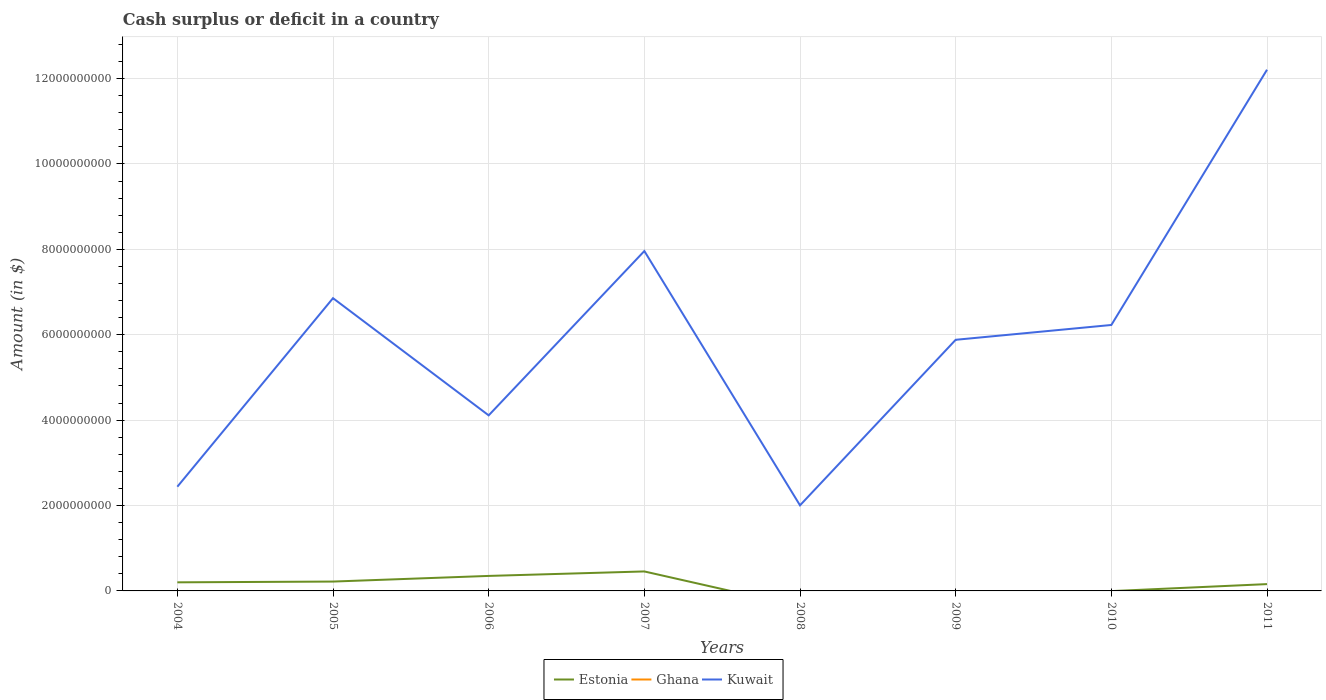How many different coloured lines are there?
Make the answer very short. 2. Does the line corresponding to Ghana intersect with the line corresponding to Estonia?
Make the answer very short. No. Across all years, what is the maximum amount of cash surplus or deficit in Kuwait?
Keep it short and to the point. 2.00e+09. What is the total amount of cash surplus or deficit in Kuwait in the graph?
Make the answer very short. -4.22e+09. What is the difference between the highest and the second highest amount of cash surplus or deficit in Estonia?
Ensure brevity in your answer.  4.56e+08. Is the amount of cash surplus or deficit in Ghana strictly greater than the amount of cash surplus or deficit in Kuwait over the years?
Offer a terse response. Yes. How many years are there in the graph?
Your response must be concise. 8. Are the values on the major ticks of Y-axis written in scientific E-notation?
Give a very brief answer. No. Does the graph contain any zero values?
Offer a terse response. Yes. Where does the legend appear in the graph?
Your answer should be very brief. Bottom center. How many legend labels are there?
Ensure brevity in your answer.  3. What is the title of the graph?
Keep it short and to the point. Cash surplus or deficit in a country. What is the label or title of the Y-axis?
Make the answer very short. Amount (in $). What is the Amount (in $) in Estonia in 2004?
Your answer should be compact. 2.01e+08. What is the Amount (in $) in Kuwait in 2004?
Ensure brevity in your answer.  2.44e+09. What is the Amount (in $) of Estonia in 2005?
Your answer should be compact. 2.19e+08. What is the Amount (in $) in Ghana in 2005?
Provide a succinct answer. 0. What is the Amount (in $) of Kuwait in 2005?
Give a very brief answer. 6.86e+09. What is the Amount (in $) of Estonia in 2006?
Offer a very short reply. 3.52e+08. What is the Amount (in $) of Ghana in 2006?
Provide a succinct answer. 0. What is the Amount (in $) of Kuwait in 2006?
Provide a succinct answer. 4.11e+09. What is the Amount (in $) of Estonia in 2007?
Provide a short and direct response. 4.56e+08. What is the Amount (in $) of Kuwait in 2007?
Your response must be concise. 7.96e+09. What is the Amount (in $) in Kuwait in 2008?
Offer a terse response. 2.00e+09. What is the Amount (in $) of Kuwait in 2009?
Your answer should be compact. 5.88e+09. What is the Amount (in $) in Kuwait in 2010?
Your answer should be very brief. 6.23e+09. What is the Amount (in $) of Estonia in 2011?
Provide a short and direct response. 1.60e+08. What is the Amount (in $) in Kuwait in 2011?
Keep it short and to the point. 1.22e+1. Across all years, what is the maximum Amount (in $) in Estonia?
Offer a very short reply. 4.56e+08. Across all years, what is the maximum Amount (in $) in Kuwait?
Your response must be concise. 1.22e+1. Across all years, what is the minimum Amount (in $) of Kuwait?
Your answer should be compact. 2.00e+09. What is the total Amount (in $) in Estonia in the graph?
Give a very brief answer. 1.39e+09. What is the total Amount (in $) of Ghana in the graph?
Offer a very short reply. 0. What is the total Amount (in $) in Kuwait in the graph?
Your answer should be compact. 4.77e+1. What is the difference between the Amount (in $) in Estonia in 2004 and that in 2005?
Ensure brevity in your answer.  -1.79e+07. What is the difference between the Amount (in $) of Kuwait in 2004 and that in 2005?
Your response must be concise. -4.42e+09. What is the difference between the Amount (in $) in Estonia in 2004 and that in 2006?
Offer a terse response. -1.50e+08. What is the difference between the Amount (in $) of Kuwait in 2004 and that in 2006?
Ensure brevity in your answer.  -1.67e+09. What is the difference between the Amount (in $) in Estonia in 2004 and that in 2007?
Give a very brief answer. -2.55e+08. What is the difference between the Amount (in $) of Kuwait in 2004 and that in 2007?
Offer a very short reply. -5.52e+09. What is the difference between the Amount (in $) in Kuwait in 2004 and that in 2008?
Your answer should be very brief. 4.36e+08. What is the difference between the Amount (in $) in Kuwait in 2004 and that in 2009?
Your response must be concise. -3.44e+09. What is the difference between the Amount (in $) in Kuwait in 2004 and that in 2010?
Make the answer very short. -3.79e+09. What is the difference between the Amount (in $) of Estonia in 2004 and that in 2011?
Make the answer very short. 4.19e+07. What is the difference between the Amount (in $) of Kuwait in 2004 and that in 2011?
Give a very brief answer. -9.77e+09. What is the difference between the Amount (in $) in Estonia in 2005 and that in 2006?
Provide a short and direct response. -1.32e+08. What is the difference between the Amount (in $) of Kuwait in 2005 and that in 2006?
Provide a succinct answer. 2.74e+09. What is the difference between the Amount (in $) in Estonia in 2005 and that in 2007?
Your answer should be compact. -2.37e+08. What is the difference between the Amount (in $) of Kuwait in 2005 and that in 2007?
Your answer should be compact. -1.10e+09. What is the difference between the Amount (in $) of Kuwait in 2005 and that in 2008?
Your answer should be compact. 4.85e+09. What is the difference between the Amount (in $) of Kuwait in 2005 and that in 2009?
Keep it short and to the point. 9.75e+08. What is the difference between the Amount (in $) of Kuwait in 2005 and that in 2010?
Your response must be concise. 6.28e+08. What is the difference between the Amount (in $) in Estonia in 2005 and that in 2011?
Your answer should be compact. 5.98e+07. What is the difference between the Amount (in $) of Kuwait in 2005 and that in 2011?
Make the answer very short. -5.35e+09. What is the difference between the Amount (in $) in Estonia in 2006 and that in 2007?
Offer a terse response. -1.05e+08. What is the difference between the Amount (in $) of Kuwait in 2006 and that in 2007?
Provide a short and direct response. -3.85e+09. What is the difference between the Amount (in $) in Kuwait in 2006 and that in 2008?
Give a very brief answer. 2.11e+09. What is the difference between the Amount (in $) of Kuwait in 2006 and that in 2009?
Provide a succinct answer. -1.77e+09. What is the difference between the Amount (in $) of Kuwait in 2006 and that in 2010?
Offer a terse response. -2.12e+09. What is the difference between the Amount (in $) of Estonia in 2006 and that in 2011?
Your answer should be very brief. 1.92e+08. What is the difference between the Amount (in $) in Kuwait in 2006 and that in 2011?
Ensure brevity in your answer.  -8.10e+09. What is the difference between the Amount (in $) in Kuwait in 2007 and that in 2008?
Make the answer very short. 5.96e+09. What is the difference between the Amount (in $) in Kuwait in 2007 and that in 2009?
Your response must be concise. 2.08e+09. What is the difference between the Amount (in $) of Kuwait in 2007 and that in 2010?
Offer a terse response. 1.73e+09. What is the difference between the Amount (in $) of Estonia in 2007 and that in 2011?
Provide a short and direct response. 2.97e+08. What is the difference between the Amount (in $) of Kuwait in 2007 and that in 2011?
Keep it short and to the point. -4.25e+09. What is the difference between the Amount (in $) of Kuwait in 2008 and that in 2009?
Your answer should be compact. -3.88e+09. What is the difference between the Amount (in $) of Kuwait in 2008 and that in 2010?
Your answer should be very brief. -4.22e+09. What is the difference between the Amount (in $) of Kuwait in 2008 and that in 2011?
Provide a succinct answer. -1.02e+1. What is the difference between the Amount (in $) in Kuwait in 2009 and that in 2010?
Your answer should be very brief. -3.47e+08. What is the difference between the Amount (in $) in Kuwait in 2009 and that in 2011?
Offer a very short reply. -6.33e+09. What is the difference between the Amount (in $) of Kuwait in 2010 and that in 2011?
Ensure brevity in your answer.  -5.98e+09. What is the difference between the Amount (in $) of Estonia in 2004 and the Amount (in $) of Kuwait in 2005?
Give a very brief answer. -6.66e+09. What is the difference between the Amount (in $) of Estonia in 2004 and the Amount (in $) of Kuwait in 2006?
Offer a terse response. -3.91e+09. What is the difference between the Amount (in $) of Estonia in 2004 and the Amount (in $) of Kuwait in 2007?
Provide a succinct answer. -7.76e+09. What is the difference between the Amount (in $) of Estonia in 2004 and the Amount (in $) of Kuwait in 2008?
Make the answer very short. -1.80e+09. What is the difference between the Amount (in $) of Estonia in 2004 and the Amount (in $) of Kuwait in 2009?
Offer a very short reply. -5.68e+09. What is the difference between the Amount (in $) in Estonia in 2004 and the Amount (in $) in Kuwait in 2010?
Your response must be concise. -6.03e+09. What is the difference between the Amount (in $) of Estonia in 2004 and the Amount (in $) of Kuwait in 2011?
Give a very brief answer. -1.20e+1. What is the difference between the Amount (in $) of Estonia in 2005 and the Amount (in $) of Kuwait in 2006?
Your answer should be very brief. -3.89e+09. What is the difference between the Amount (in $) of Estonia in 2005 and the Amount (in $) of Kuwait in 2007?
Make the answer very short. -7.74e+09. What is the difference between the Amount (in $) in Estonia in 2005 and the Amount (in $) in Kuwait in 2008?
Your answer should be compact. -1.79e+09. What is the difference between the Amount (in $) of Estonia in 2005 and the Amount (in $) of Kuwait in 2009?
Offer a terse response. -5.66e+09. What is the difference between the Amount (in $) of Estonia in 2005 and the Amount (in $) of Kuwait in 2010?
Give a very brief answer. -6.01e+09. What is the difference between the Amount (in $) of Estonia in 2005 and the Amount (in $) of Kuwait in 2011?
Keep it short and to the point. -1.20e+1. What is the difference between the Amount (in $) of Estonia in 2006 and the Amount (in $) of Kuwait in 2007?
Offer a terse response. -7.61e+09. What is the difference between the Amount (in $) in Estonia in 2006 and the Amount (in $) in Kuwait in 2008?
Your answer should be compact. -1.65e+09. What is the difference between the Amount (in $) in Estonia in 2006 and the Amount (in $) in Kuwait in 2009?
Ensure brevity in your answer.  -5.53e+09. What is the difference between the Amount (in $) in Estonia in 2006 and the Amount (in $) in Kuwait in 2010?
Your response must be concise. -5.88e+09. What is the difference between the Amount (in $) in Estonia in 2006 and the Amount (in $) in Kuwait in 2011?
Give a very brief answer. -1.19e+1. What is the difference between the Amount (in $) in Estonia in 2007 and the Amount (in $) in Kuwait in 2008?
Make the answer very short. -1.55e+09. What is the difference between the Amount (in $) in Estonia in 2007 and the Amount (in $) in Kuwait in 2009?
Your response must be concise. -5.43e+09. What is the difference between the Amount (in $) in Estonia in 2007 and the Amount (in $) in Kuwait in 2010?
Your response must be concise. -5.77e+09. What is the difference between the Amount (in $) of Estonia in 2007 and the Amount (in $) of Kuwait in 2011?
Provide a short and direct response. -1.18e+1. What is the average Amount (in $) of Estonia per year?
Make the answer very short. 1.73e+08. What is the average Amount (in $) of Kuwait per year?
Provide a short and direct response. 5.96e+09. In the year 2004, what is the difference between the Amount (in $) in Estonia and Amount (in $) in Kuwait?
Provide a succinct answer. -2.24e+09. In the year 2005, what is the difference between the Amount (in $) in Estonia and Amount (in $) in Kuwait?
Make the answer very short. -6.64e+09. In the year 2006, what is the difference between the Amount (in $) of Estonia and Amount (in $) of Kuwait?
Provide a short and direct response. -3.76e+09. In the year 2007, what is the difference between the Amount (in $) in Estonia and Amount (in $) in Kuwait?
Provide a succinct answer. -7.50e+09. In the year 2011, what is the difference between the Amount (in $) in Estonia and Amount (in $) in Kuwait?
Your response must be concise. -1.20e+1. What is the ratio of the Amount (in $) in Estonia in 2004 to that in 2005?
Give a very brief answer. 0.92. What is the ratio of the Amount (in $) of Kuwait in 2004 to that in 2005?
Offer a very short reply. 0.36. What is the ratio of the Amount (in $) in Estonia in 2004 to that in 2006?
Provide a short and direct response. 0.57. What is the ratio of the Amount (in $) in Kuwait in 2004 to that in 2006?
Offer a terse response. 0.59. What is the ratio of the Amount (in $) of Estonia in 2004 to that in 2007?
Give a very brief answer. 0.44. What is the ratio of the Amount (in $) in Kuwait in 2004 to that in 2007?
Offer a very short reply. 0.31. What is the ratio of the Amount (in $) of Kuwait in 2004 to that in 2008?
Make the answer very short. 1.22. What is the ratio of the Amount (in $) of Kuwait in 2004 to that in 2009?
Your answer should be very brief. 0.41. What is the ratio of the Amount (in $) of Kuwait in 2004 to that in 2010?
Provide a short and direct response. 0.39. What is the ratio of the Amount (in $) of Estonia in 2004 to that in 2011?
Give a very brief answer. 1.26. What is the ratio of the Amount (in $) of Estonia in 2005 to that in 2006?
Provide a short and direct response. 0.62. What is the ratio of the Amount (in $) of Kuwait in 2005 to that in 2006?
Ensure brevity in your answer.  1.67. What is the ratio of the Amount (in $) of Estonia in 2005 to that in 2007?
Offer a very short reply. 0.48. What is the ratio of the Amount (in $) in Kuwait in 2005 to that in 2007?
Provide a succinct answer. 0.86. What is the ratio of the Amount (in $) in Kuwait in 2005 to that in 2008?
Offer a terse response. 3.42. What is the ratio of the Amount (in $) in Kuwait in 2005 to that in 2009?
Provide a short and direct response. 1.17. What is the ratio of the Amount (in $) in Kuwait in 2005 to that in 2010?
Give a very brief answer. 1.1. What is the ratio of the Amount (in $) in Estonia in 2005 to that in 2011?
Offer a very short reply. 1.37. What is the ratio of the Amount (in $) of Kuwait in 2005 to that in 2011?
Make the answer very short. 0.56. What is the ratio of the Amount (in $) in Estonia in 2006 to that in 2007?
Provide a short and direct response. 0.77. What is the ratio of the Amount (in $) in Kuwait in 2006 to that in 2007?
Ensure brevity in your answer.  0.52. What is the ratio of the Amount (in $) in Kuwait in 2006 to that in 2008?
Make the answer very short. 2.05. What is the ratio of the Amount (in $) in Kuwait in 2006 to that in 2009?
Make the answer very short. 0.7. What is the ratio of the Amount (in $) in Kuwait in 2006 to that in 2010?
Your answer should be very brief. 0.66. What is the ratio of the Amount (in $) in Estonia in 2006 to that in 2011?
Your answer should be very brief. 2.2. What is the ratio of the Amount (in $) in Kuwait in 2006 to that in 2011?
Offer a terse response. 0.34. What is the ratio of the Amount (in $) of Kuwait in 2007 to that in 2008?
Ensure brevity in your answer.  3.97. What is the ratio of the Amount (in $) in Kuwait in 2007 to that in 2009?
Your answer should be compact. 1.35. What is the ratio of the Amount (in $) in Kuwait in 2007 to that in 2010?
Provide a succinct answer. 1.28. What is the ratio of the Amount (in $) of Estonia in 2007 to that in 2011?
Your answer should be very brief. 2.86. What is the ratio of the Amount (in $) of Kuwait in 2007 to that in 2011?
Your answer should be compact. 0.65. What is the ratio of the Amount (in $) of Kuwait in 2008 to that in 2009?
Your answer should be compact. 0.34. What is the ratio of the Amount (in $) of Kuwait in 2008 to that in 2010?
Offer a terse response. 0.32. What is the ratio of the Amount (in $) in Kuwait in 2008 to that in 2011?
Your response must be concise. 0.16. What is the ratio of the Amount (in $) of Kuwait in 2009 to that in 2010?
Offer a very short reply. 0.94. What is the ratio of the Amount (in $) in Kuwait in 2009 to that in 2011?
Offer a very short reply. 0.48. What is the ratio of the Amount (in $) of Kuwait in 2010 to that in 2011?
Keep it short and to the point. 0.51. What is the difference between the highest and the second highest Amount (in $) in Estonia?
Your answer should be compact. 1.05e+08. What is the difference between the highest and the second highest Amount (in $) of Kuwait?
Provide a short and direct response. 4.25e+09. What is the difference between the highest and the lowest Amount (in $) of Estonia?
Keep it short and to the point. 4.56e+08. What is the difference between the highest and the lowest Amount (in $) in Kuwait?
Provide a succinct answer. 1.02e+1. 